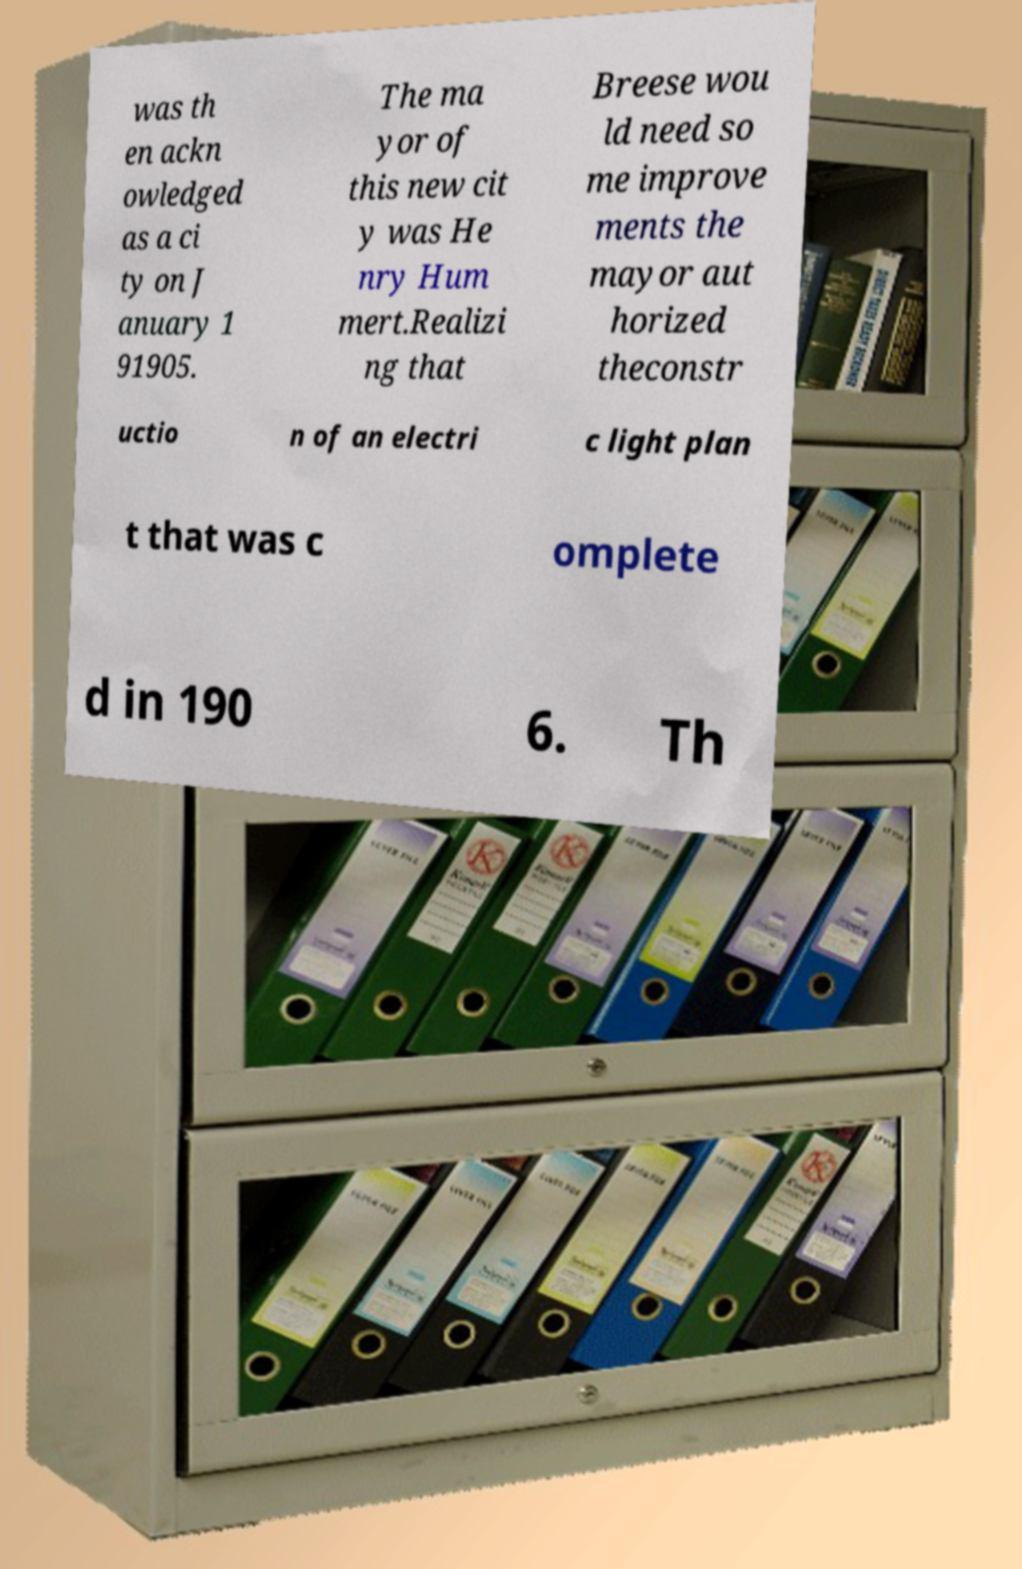Could you assist in decoding the text presented in this image and type it out clearly? was th en ackn owledged as a ci ty on J anuary 1 91905. The ma yor of this new cit y was He nry Hum mert.Realizi ng that Breese wou ld need so me improve ments the mayor aut horized theconstr uctio n of an electri c light plan t that was c omplete d in 190 6. Th 